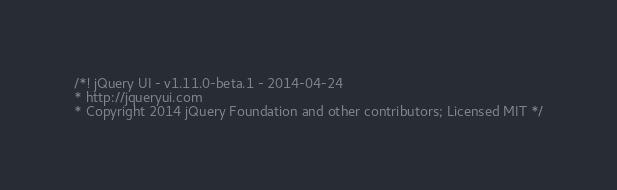Convert code to text. <code><loc_0><loc_0><loc_500><loc_500><_JavaScript_>/*! jQuery UI - v1.11.0-beta.1 - 2014-04-24
* http://jqueryui.com
* Copyright 2014 jQuery Foundation and other contributors; Licensed MIT */
</code> 